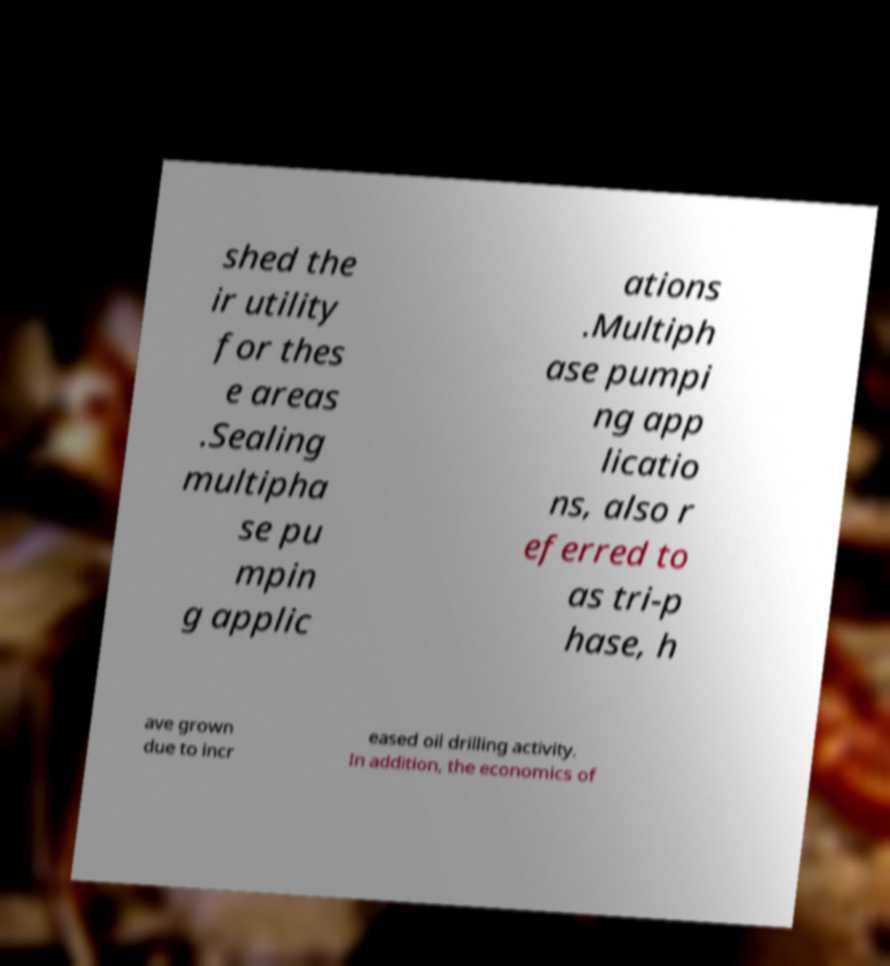Can you accurately transcribe the text from the provided image for me? shed the ir utility for thes e areas .Sealing multipha se pu mpin g applic ations .Multiph ase pumpi ng app licatio ns, also r eferred to as tri-p hase, h ave grown due to incr eased oil drilling activity. In addition, the economics of 